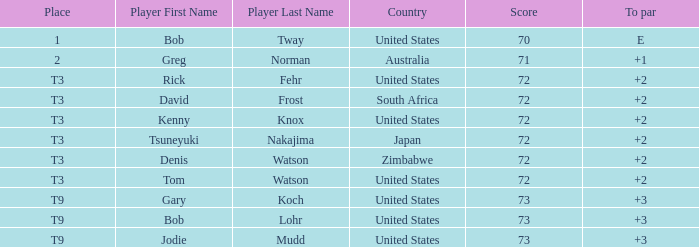What is the low score for TO par +2 in japan? 72.0. I'm looking to parse the entire table for insights. Could you assist me with that? {'header': ['Place', 'Player First Name', 'Player Last Name', 'Country', 'Score', 'To par'], 'rows': [['1', 'Bob', 'Tway', 'United States', '70', 'E'], ['2', 'Greg', 'Norman', 'Australia', '71', '+1'], ['T3', 'Rick', 'Fehr', 'United States', '72', '+2'], ['T3', 'David', 'Frost', 'South Africa', '72', '+2'], ['T3', 'Kenny', 'Knox', 'United States', '72', '+2'], ['T3', 'Tsuneyuki', 'Nakajima', 'Japan', '72', '+2'], ['T3', 'Denis', 'Watson', 'Zimbabwe', '72', '+2'], ['T3', 'Tom', 'Watson', 'United States', '72', '+2'], ['T9', 'Gary', 'Koch', 'United States', '73', '+3'], ['T9', 'Bob', 'Lohr', 'United States', '73', '+3'], ['T9', 'Jodie', 'Mudd', 'United States', '73', '+3']]} 